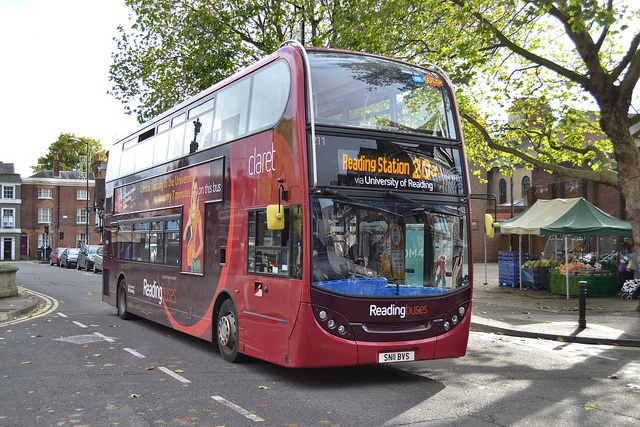Describe the objects in this image and their specific colors. I can see bus in white, gray, black, lightgray, and brown tones, people in white, gray, black, and darkgray tones, car in white, gray, lightgray, black, and darkgray tones, people in white, gray, darkgray, and brown tones, and car in white, gray, and black tones in this image. 